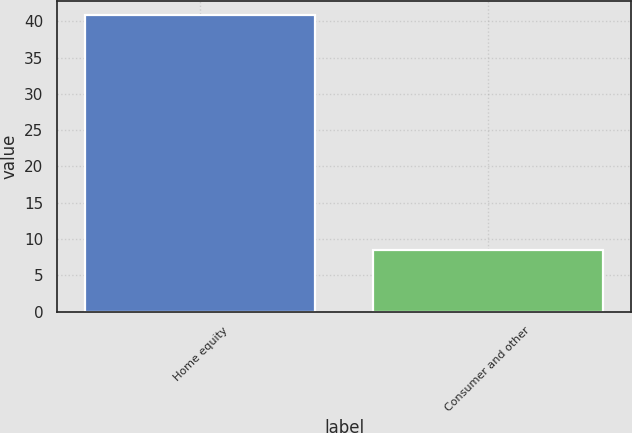Convert chart to OTSL. <chart><loc_0><loc_0><loc_500><loc_500><bar_chart><fcel>Home equity<fcel>Consumer and other<nl><fcel>40.8<fcel>8.5<nl></chart> 